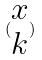<formula> <loc_0><loc_0><loc_500><loc_500>( \begin{matrix} x \\ k \end{matrix} )</formula> 